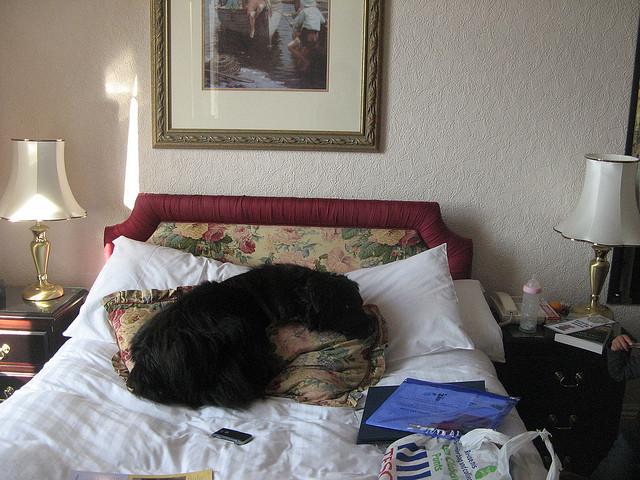Is the bed frame embroidered in red?
Answer briefly. Yes. Does the dog look like it owns the bed?
Write a very short answer. Yes. Which side of the bed is cluttered?
Keep it brief. Right. 